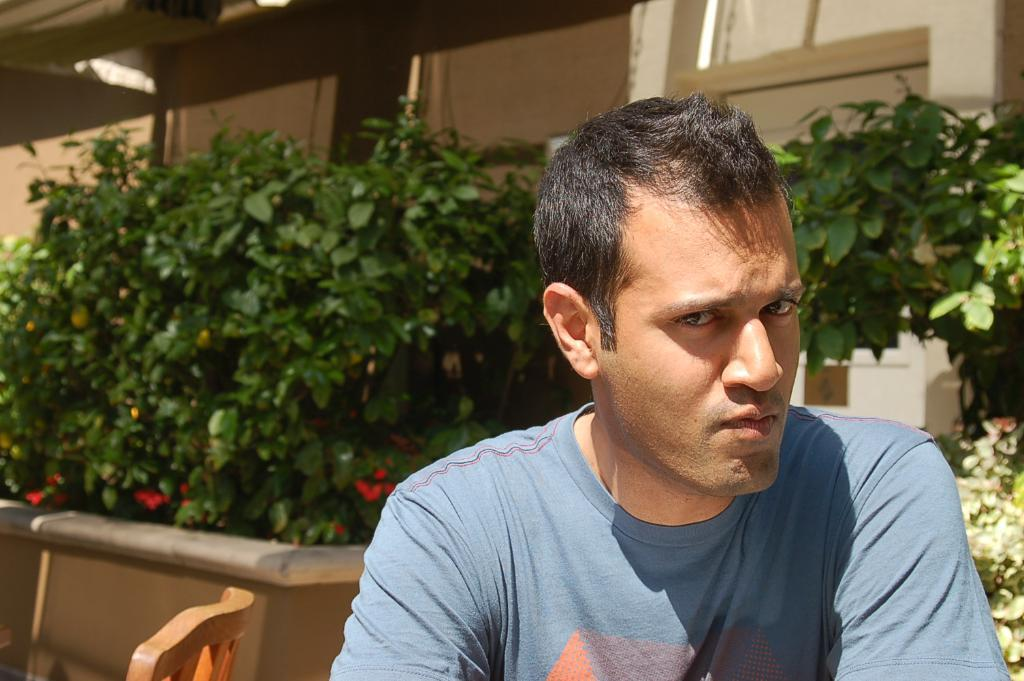Who or what is in the front of the image? There is a person in the front of the image. What can be seen in the background of the image? There are plants and a building in the background of the image. What type of lace can be seen on the person's clothing in the image? There is no lace visible on the person's clothing in the image. Is there an advertisement for a hospital in the background of the image? There is no advertisement or reference to a hospital in the image. 